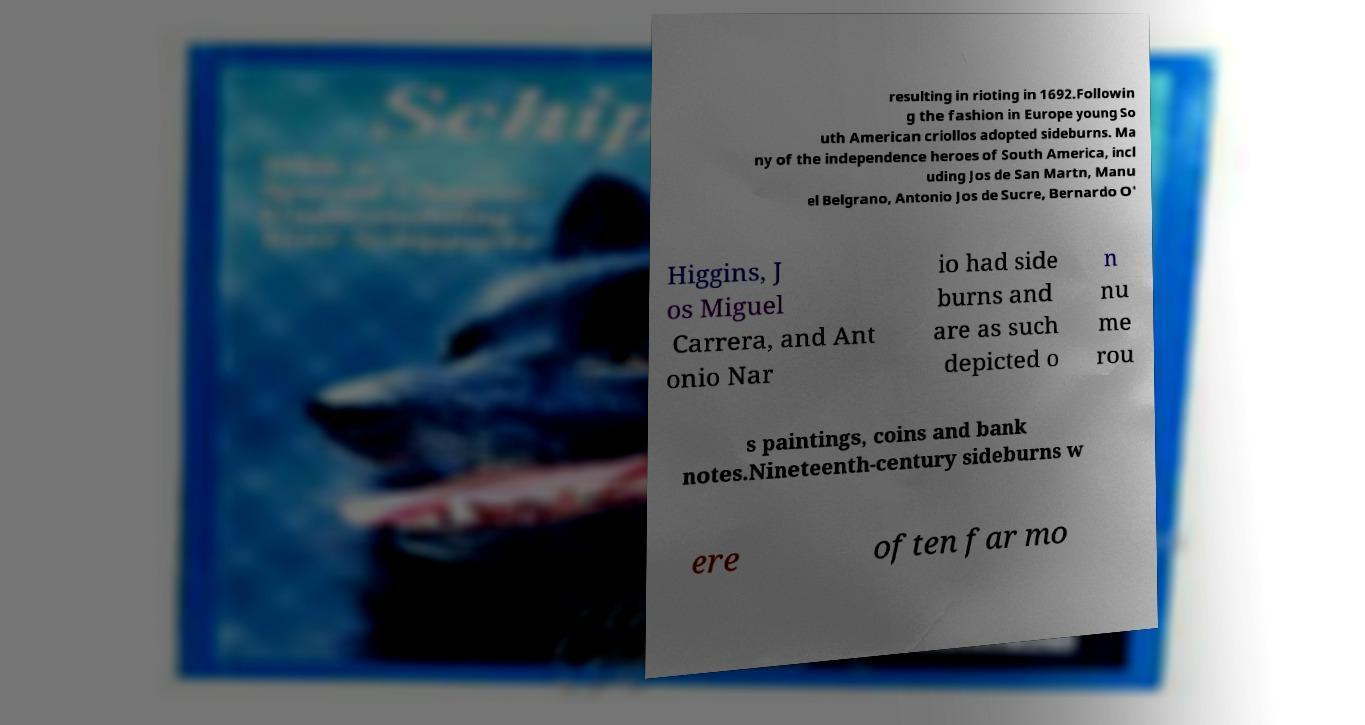I need the written content from this picture converted into text. Can you do that? resulting in rioting in 1692.Followin g the fashion in Europe young So uth American criollos adopted sideburns. Ma ny of the independence heroes of South America, incl uding Jos de San Martn, Manu el Belgrano, Antonio Jos de Sucre, Bernardo O' Higgins, J os Miguel Carrera, and Ant onio Nar io had side burns and are as such depicted o n nu me rou s paintings, coins and bank notes.Nineteenth-century sideburns w ere often far mo 